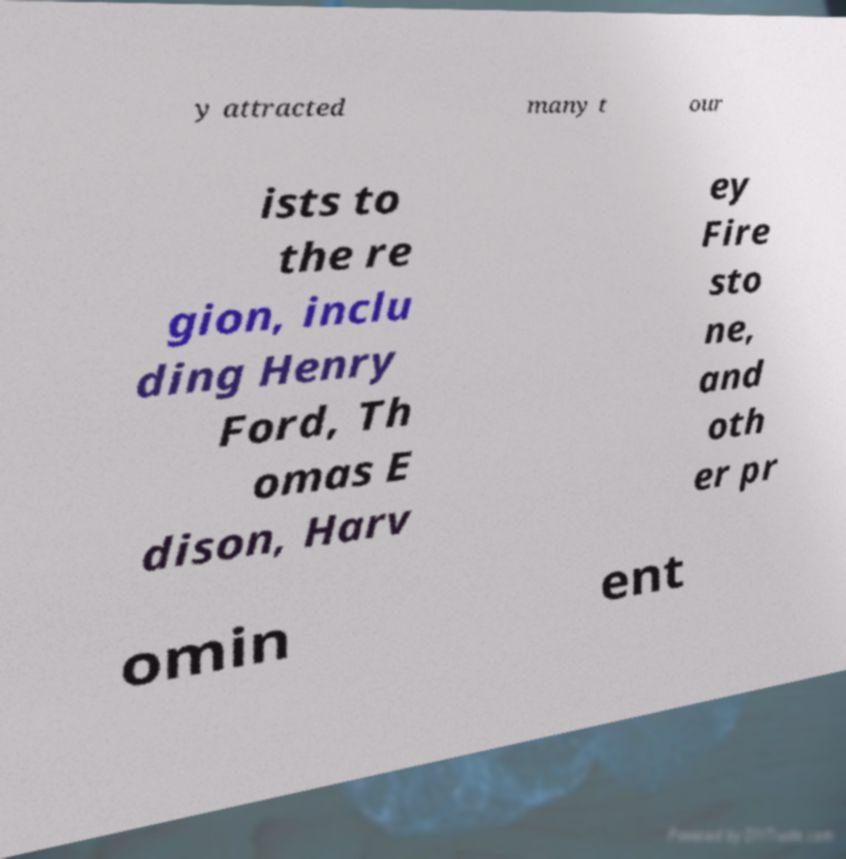I need the written content from this picture converted into text. Can you do that? y attracted many t our ists to the re gion, inclu ding Henry Ford, Th omas E dison, Harv ey Fire sto ne, and oth er pr omin ent 